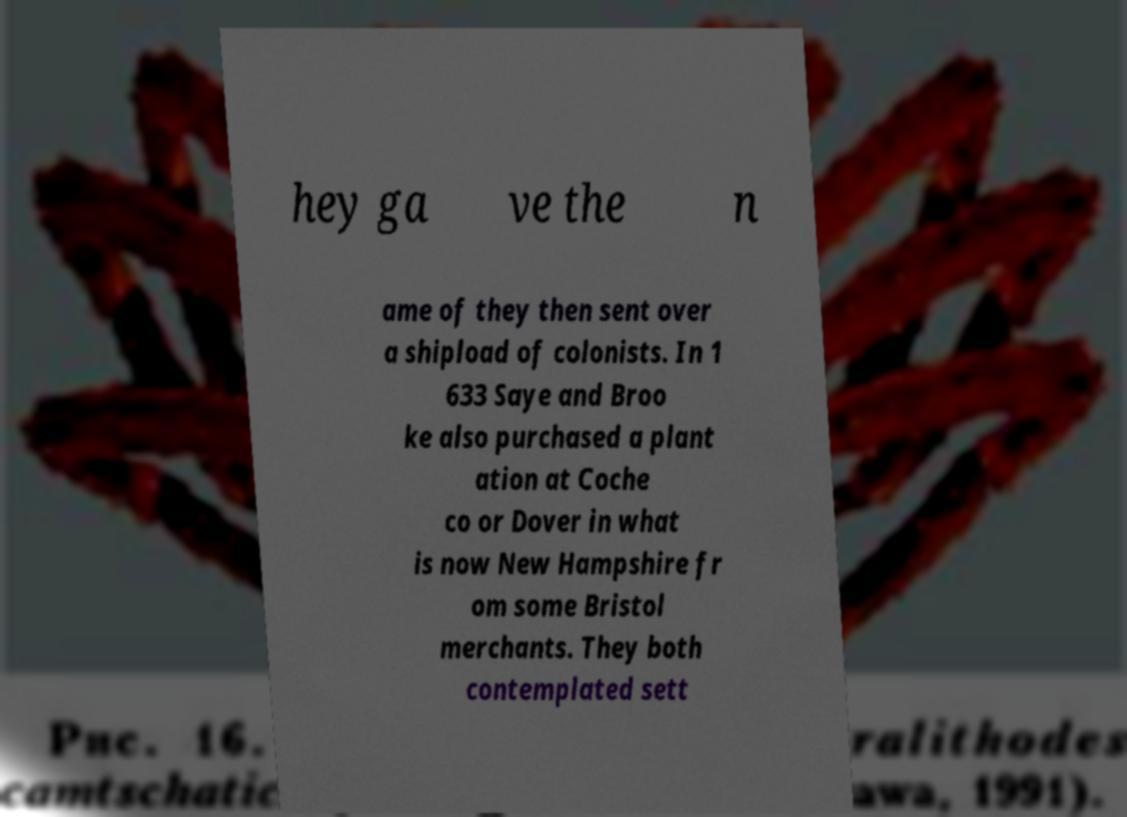Could you extract and type out the text from this image? hey ga ve the n ame of they then sent over a shipload of colonists. In 1 633 Saye and Broo ke also purchased a plant ation at Coche co or Dover in what is now New Hampshire fr om some Bristol merchants. They both contemplated sett 